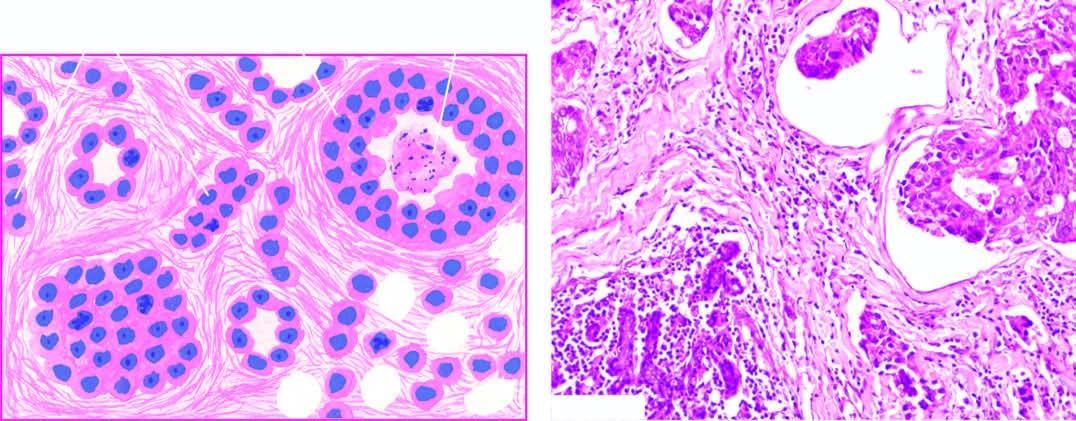s side infiltration of densely collagenised stroma by these cells in a haphazard manner?
Answer the question using a single word or phrase. No 